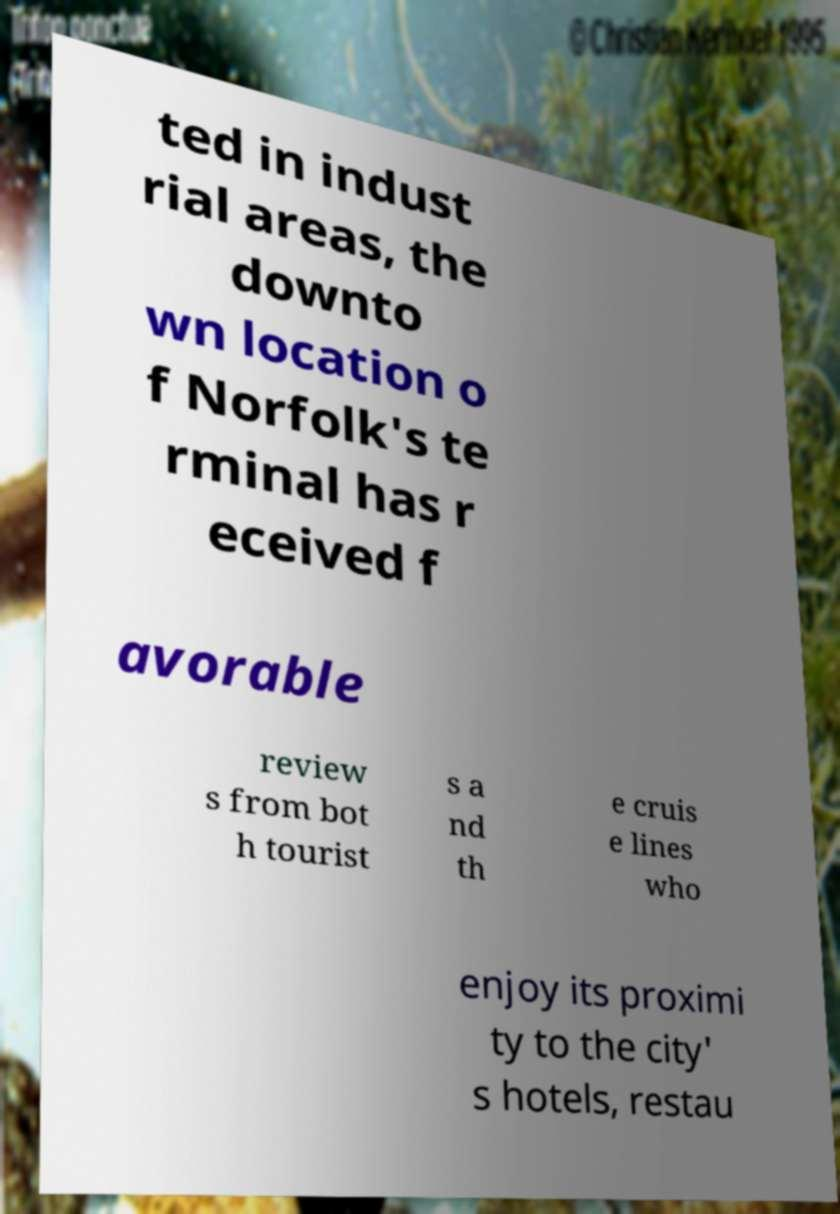For documentation purposes, I need the text within this image transcribed. Could you provide that? ted in indust rial areas, the downto wn location o f Norfolk's te rminal has r eceived f avorable review s from bot h tourist s a nd th e cruis e lines who enjoy its proximi ty to the city' s hotels, restau 